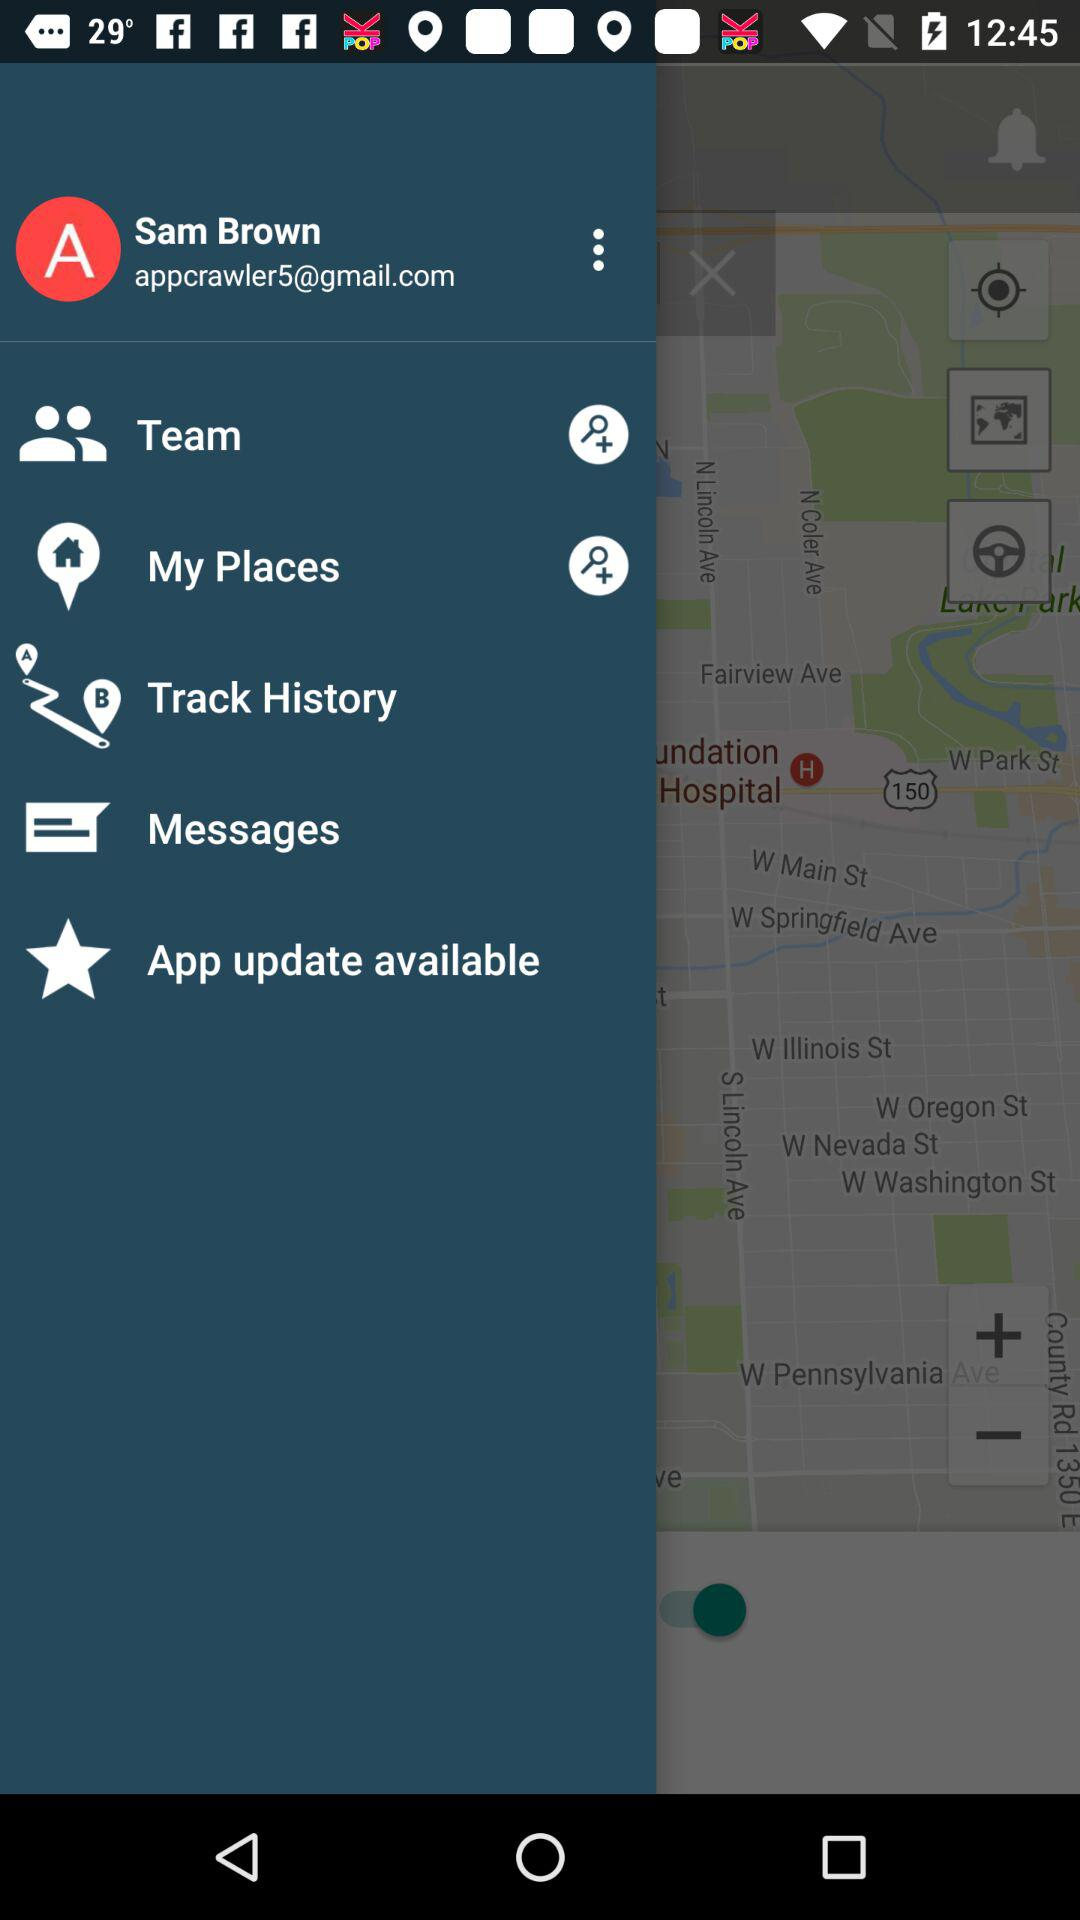What is an email address? The email address is appcrawler5@gmail.com. 